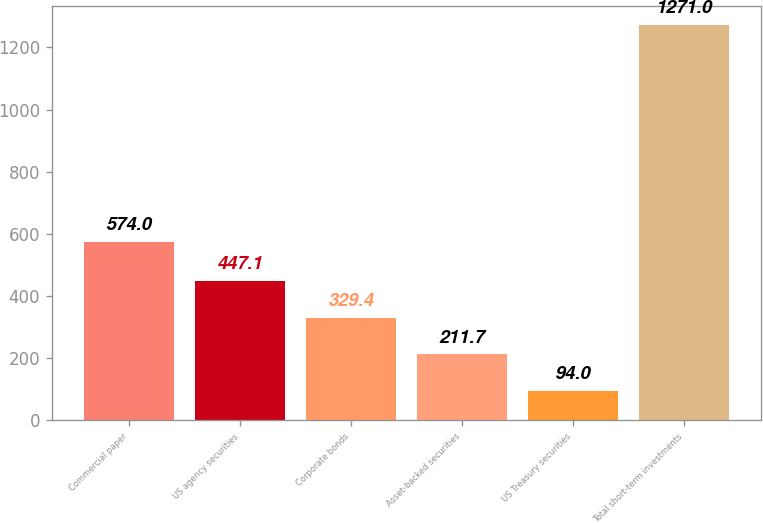<chart> <loc_0><loc_0><loc_500><loc_500><bar_chart><fcel>Commercial paper<fcel>US agency securities<fcel>Corporate bonds<fcel>Asset-backed securities<fcel>US Treasury securities<fcel>Total short-term investments<nl><fcel>574<fcel>447.1<fcel>329.4<fcel>211.7<fcel>94<fcel>1271<nl></chart> 